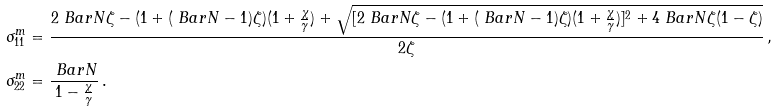Convert formula to latex. <formula><loc_0><loc_0><loc_500><loc_500>\sigma _ { 1 1 } ^ { m } & = \frac { 2 { \ B a r { N } } \zeta - ( 1 + ( \ B a r { N } - 1 ) \zeta ) ( 1 + \frac { \chi } { \gamma } ) + \sqrt { [ 2 { \ B a r { N } } \zeta - ( 1 + ( \ B a r { N } - 1 ) \zeta ) ( 1 + \frac { \chi } { \gamma } ) ] ^ { 2 } + 4 \ B a r { N } \zeta ( 1 - \zeta ) } } { 2 \zeta } \, , \\ \sigma _ { 2 2 } ^ { m } & = \frac { \ B a r { N } } { 1 - \frac { \chi } { \gamma } } \, .</formula> 